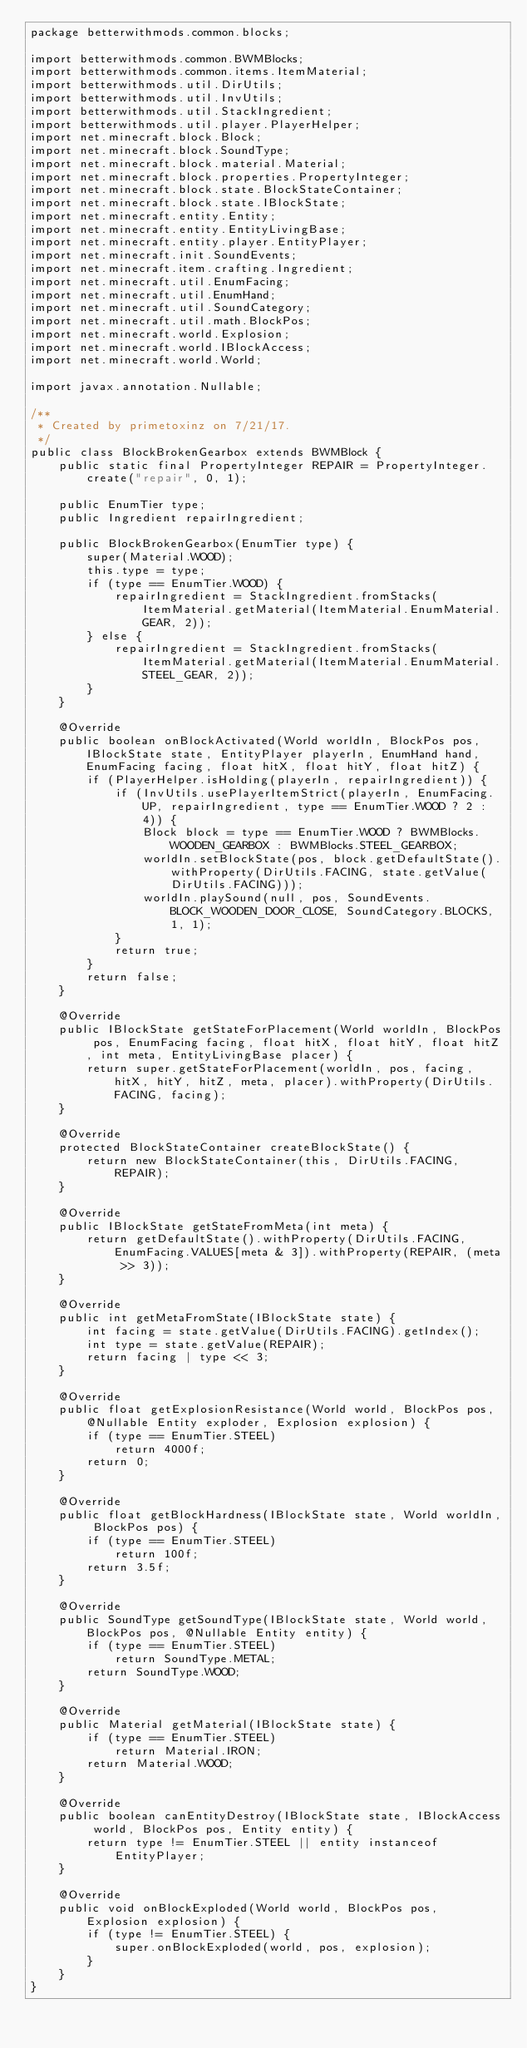Convert code to text. <code><loc_0><loc_0><loc_500><loc_500><_Java_>package betterwithmods.common.blocks;

import betterwithmods.common.BWMBlocks;
import betterwithmods.common.items.ItemMaterial;
import betterwithmods.util.DirUtils;
import betterwithmods.util.InvUtils;
import betterwithmods.util.StackIngredient;
import betterwithmods.util.player.PlayerHelper;
import net.minecraft.block.Block;
import net.minecraft.block.SoundType;
import net.minecraft.block.material.Material;
import net.minecraft.block.properties.PropertyInteger;
import net.minecraft.block.state.BlockStateContainer;
import net.minecraft.block.state.IBlockState;
import net.minecraft.entity.Entity;
import net.minecraft.entity.EntityLivingBase;
import net.minecraft.entity.player.EntityPlayer;
import net.minecraft.init.SoundEvents;
import net.minecraft.item.crafting.Ingredient;
import net.minecraft.util.EnumFacing;
import net.minecraft.util.EnumHand;
import net.minecraft.util.SoundCategory;
import net.minecraft.util.math.BlockPos;
import net.minecraft.world.Explosion;
import net.minecraft.world.IBlockAccess;
import net.minecraft.world.World;

import javax.annotation.Nullable;

/**
 * Created by primetoxinz on 7/21/17.
 */
public class BlockBrokenGearbox extends BWMBlock {
    public static final PropertyInteger REPAIR = PropertyInteger.create("repair", 0, 1);

    public EnumTier type;
    public Ingredient repairIngredient;

    public BlockBrokenGearbox(EnumTier type) {
        super(Material.WOOD);
        this.type = type;
        if (type == EnumTier.WOOD) {
            repairIngredient = StackIngredient.fromStacks(ItemMaterial.getMaterial(ItemMaterial.EnumMaterial.GEAR, 2));
        } else {
            repairIngredient = StackIngredient.fromStacks(ItemMaterial.getMaterial(ItemMaterial.EnumMaterial.STEEL_GEAR, 2));
        }
    }

    @Override
    public boolean onBlockActivated(World worldIn, BlockPos pos, IBlockState state, EntityPlayer playerIn, EnumHand hand, EnumFacing facing, float hitX, float hitY, float hitZ) {
        if (PlayerHelper.isHolding(playerIn, repairIngredient)) {
            if (InvUtils.usePlayerItemStrict(playerIn, EnumFacing.UP, repairIngredient, type == EnumTier.WOOD ? 2 : 4)) {
                Block block = type == EnumTier.WOOD ? BWMBlocks.WOODEN_GEARBOX : BWMBlocks.STEEL_GEARBOX;
                worldIn.setBlockState(pos, block.getDefaultState().withProperty(DirUtils.FACING, state.getValue(DirUtils.FACING)));
                worldIn.playSound(null, pos, SoundEvents.BLOCK_WOODEN_DOOR_CLOSE, SoundCategory.BLOCKS, 1, 1);
            }
            return true;
        }
        return false;
    }

    @Override
    public IBlockState getStateForPlacement(World worldIn, BlockPos pos, EnumFacing facing, float hitX, float hitY, float hitZ, int meta, EntityLivingBase placer) {
        return super.getStateForPlacement(worldIn, pos, facing, hitX, hitY, hitZ, meta, placer).withProperty(DirUtils.FACING, facing);
    }

    @Override
    protected BlockStateContainer createBlockState() {
        return new BlockStateContainer(this, DirUtils.FACING, REPAIR);
    }

    @Override
    public IBlockState getStateFromMeta(int meta) {
        return getDefaultState().withProperty(DirUtils.FACING, EnumFacing.VALUES[meta & 3]).withProperty(REPAIR, (meta >> 3));
    }

    @Override
    public int getMetaFromState(IBlockState state) {
        int facing = state.getValue(DirUtils.FACING).getIndex();
        int type = state.getValue(REPAIR);
        return facing | type << 3;
    }

    @Override
    public float getExplosionResistance(World world, BlockPos pos, @Nullable Entity exploder, Explosion explosion) {
        if (type == EnumTier.STEEL)
            return 4000f;
        return 0;
    }

    @Override
    public float getBlockHardness(IBlockState state, World worldIn, BlockPos pos) {
        if (type == EnumTier.STEEL)
            return 100f;
        return 3.5f;
    }

    @Override
    public SoundType getSoundType(IBlockState state, World world, BlockPos pos, @Nullable Entity entity) {
        if (type == EnumTier.STEEL)
            return SoundType.METAL;
        return SoundType.WOOD;
    }

    @Override
    public Material getMaterial(IBlockState state) {
        if (type == EnumTier.STEEL)
            return Material.IRON;
        return Material.WOOD;
    }

    @Override
    public boolean canEntityDestroy(IBlockState state, IBlockAccess world, BlockPos pos, Entity entity) {
        return type != EnumTier.STEEL || entity instanceof EntityPlayer;
    }

    @Override
    public void onBlockExploded(World world, BlockPos pos, Explosion explosion) {
        if (type != EnumTier.STEEL) {
            super.onBlockExploded(world, pos, explosion);
        }
    }
}
</code> 